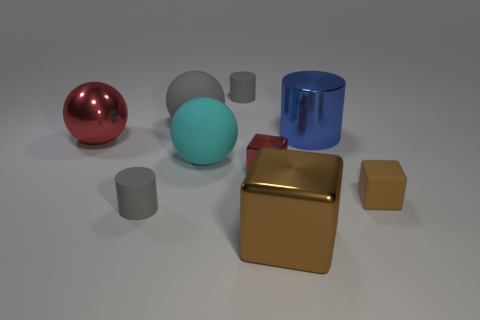Subtract all small cubes. How many cubes are left? 1 Subtract all cyan spheres. How many spheres are left? 2 Subtract all cylinders. How many objects are left? 6 Subtract 1 cylinders. How many cylinders are left? 2 Add 5 large metal objects. How many large metal objects are left? 8 Add 3 small gray rubber things. How many small gray rubber things exist? 5 Add 1 small blue things. How many objects exist? 10 Subtract 0 purple blocks. How many objects are left? 9 Subtract all green spheres. Subtract all blue cylinders. How many spheres are left? 3 Subtract all gray balls. How many yellow cubes are left? 0 